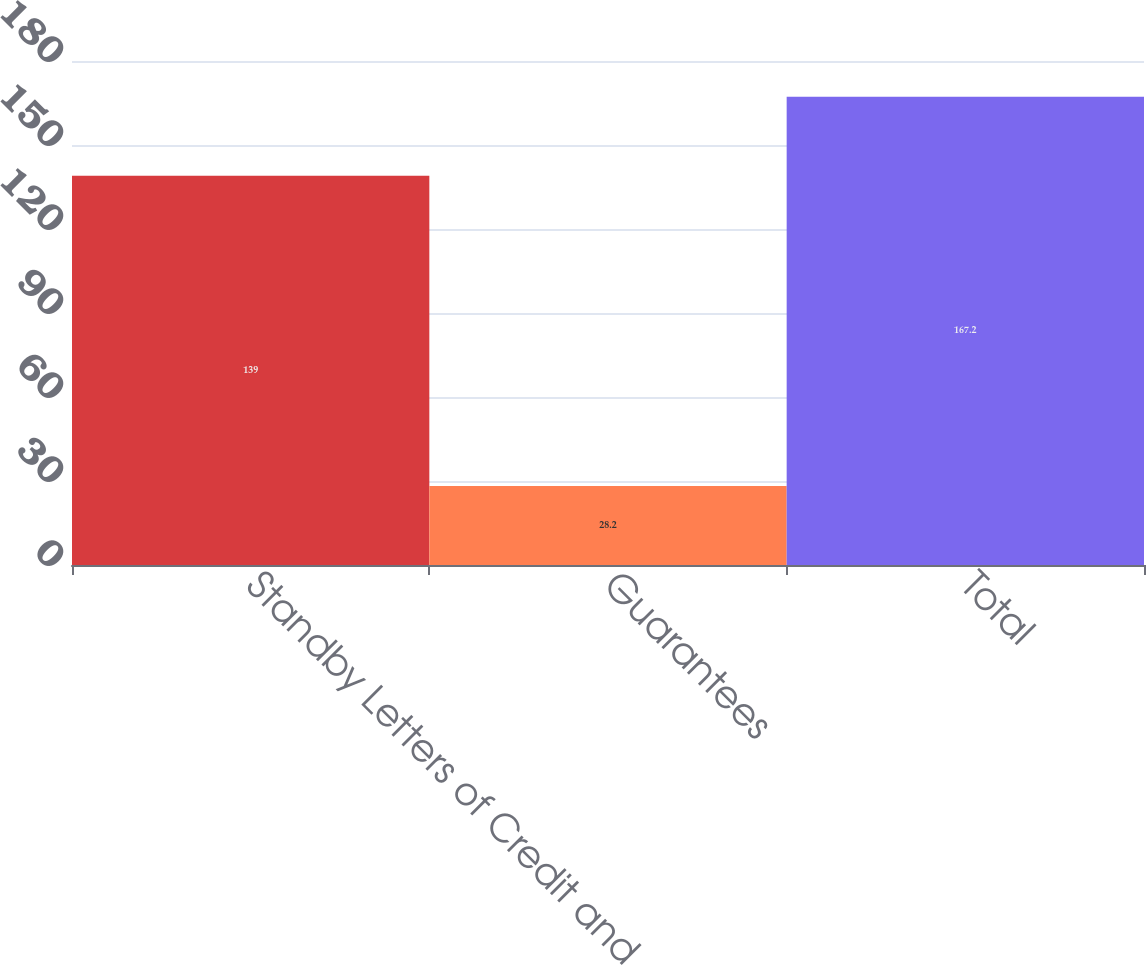<chart> <loc_0><loc_0><loc_500><loc_500><bar_chart><fcel>Standby Letters of Credit and<fcel>Guarantees<fcel>Total<nl><fcel>139<fcel>28.2<fcel>167.2<nl></chart> 